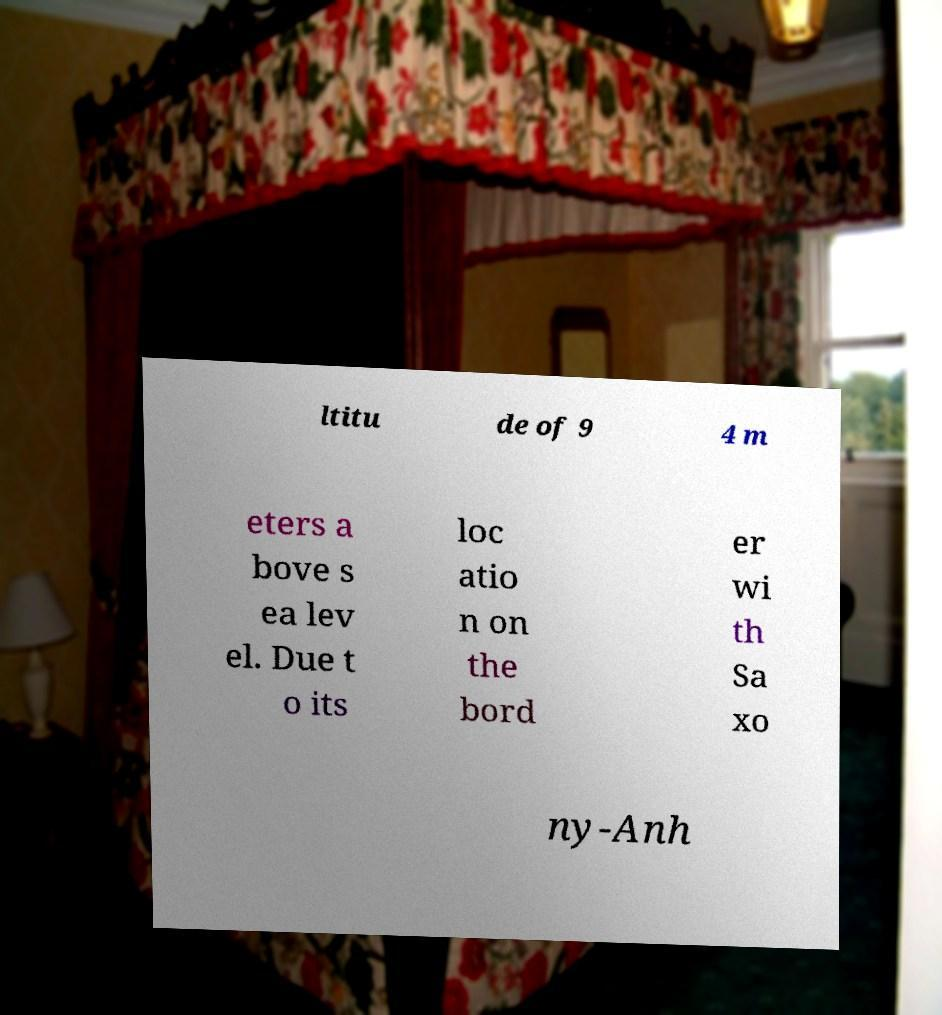Could you extract and type out the text from this image? ltitu de of 9 4 m eters a bove s ea lev el. Due t o its loc atio n on the bord er wi th Sa xo ny-Anh 